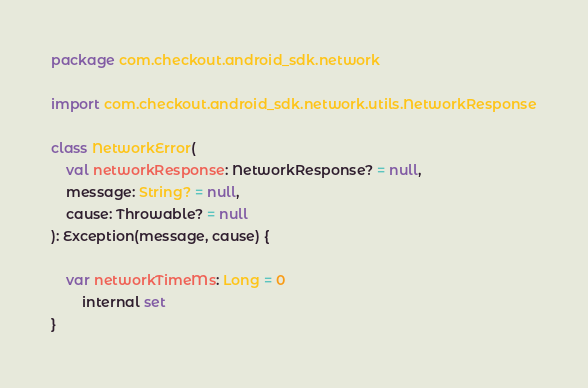<code> <loc_0><loc_0><loc_500><loc_500><_Kotlin_>package com.checkout.android_sdk.network

import com.checkout.android_sdk.network.utils.NetworkResponse

class NetworkError(
    val networkResponse: NetworkResponse? = null,
    message: String? = null,
    cause: Throwable? = null
): Exception(message, cause) {

    var networkTimeMs: Long = 0
        internal set
}</code> 